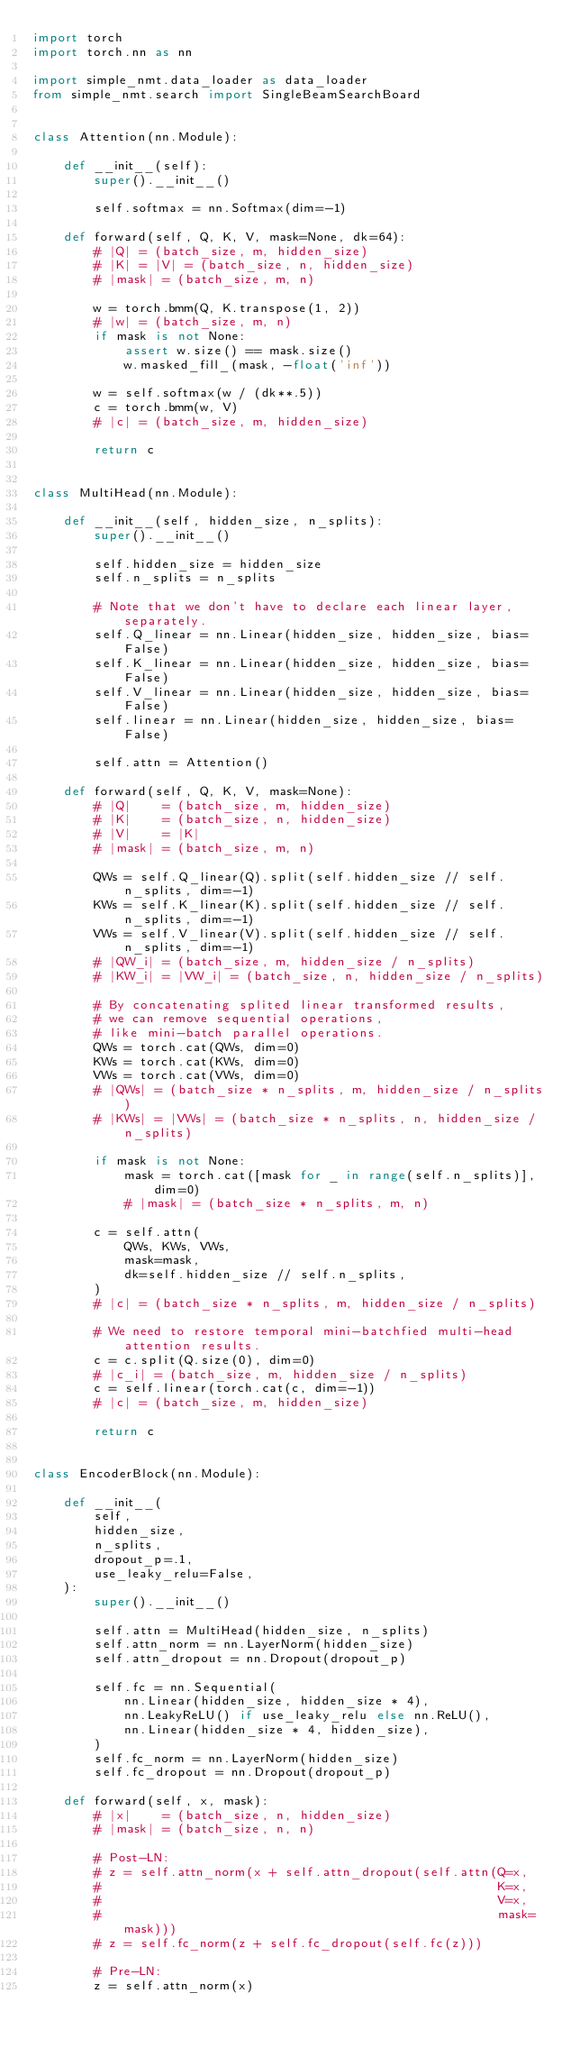Convert code to text. <code><loc_0><loc_0><loc_500><loc_500><_Python_>import torch
import torch.nn as nn

import simple_nmt.data_loader as data_loader
from simple_nmt.search import SingleBeamSearchBoard


class Attention(nn.Module):

    def __init__(self):
        super().__init__()

        self.softmax = nn.Softmax(dim=-1)

    def forward(self, Q, K, V, mask=None, dk=64):
        # |Q| = (batch_size, m, hidden_size)
        # |K| = |V| = (batch_size, n, hidden_size)
        # |mask| = (batch_size, m, n)

        w = torch.bmm(Q, K.transpose(1, 2))
        # |w| = (batch_size, m, n)
        if mask is not None:
            assert w.size() == mask.size()
            w.masked_fill_(mask, -float('inf'))

        w = self.softmax(w / (dk**.5))
        c = torch.bmm(w, V)
        # |c| = (batch_size, m, hidden_size)

        return c


class MultiHead(nn.Module):

    def __init__(self, hidden_size, n_splits):
        super().__init__()

        self.hidden_size = hidden_size
        self.n_splits = n_splits

        # Note that we don't have to declare each linear layer, separately.
        self.Q_linear = nn.Linear(hidden_size, hidden_size, bias=False)
        self.K_linear = nn.Linear(hidden_size, hidden_size, bias=False)
        self.V_linear = nn.Linear(hidden_size, hidden_size, bias=False)
        self.linear = nn.Linear(hidden_size, hidden_size, bias=False)

        self.attn = Attention()

    def forward(self, Q, K, V, mask=None):
        # |Q|    = (batch_size, m, hidden_size)
        # |K|    = (batch_size, n, hidden_size)
        # |V|    = |K|
        # |mask| = (batch_size, m, n)

        QWs = self.Q_linear(Q).split(self.hidden_size // self.n_splits, dim=-1)
        KWs = self.K_linear(K).split(self.hidden_size // self.n_splits, dim=-1)
        VWs = self.V_linear(V).split(self.hidden_size // self.n_splits, dim=-1)
        # |QW_i| = (batch_size, m, hidden_size / n_splits)
        # |KW_i| = |VW_i| = (batch_size, n, hidden_size / n_splits)

        # By concatenating splited linear transformed results,
        # we can remove sequential operations,
        # like mini-batch parallel operations.
        QWs = torch.cat(QWs, dim=0)
        KWs = torch.cat(KWs, dim=0)
        VWs = torch.cat(VWs, dim=0)
        # |QWs| = (batch_size * n_splits, m, hidden_size / n_splits)
        # |KWs| = |VWs| = (batch_size * n_splits, n, hidden_size / n_splits)

        if mask is not None:
            mask = torch.cat([mask for _ in range(self.n_splits)], dim=0)
            # |mask| = (batch_size * n_splits, m, n)

        c = self.attn(
            QWs, KWs, VWs,
            mask=mask,
            dk=self.hidden_size // self.n_splits,
        )
        # |c| = (batch_size * n_splits, m, hidden_size / n_splits)

        # We need to restore temporal mini-batchfied multi-head attention results.
        c = c.split(Q.size(0), dim=0)
        # |c_i| = (batch_size, m, hidden_size / n_splits)
        c = self.linear(torch.cat(c, dim=-1))
        # |c| = (batch_size, m, hidden_size)

        return c


class EncoderBlock(nn.Module):

    def __init__(
        self,
        hidden_size,
        n_splits,
        dropout_p=.1,
        use_leaky_relu=False,
    ):
        super().__init__()

        self.attn = MultiHead(hidden_size, n_splits)
        self.attn_norm = nn.LayerNorm(hidden_size)
        self.attn_dropout = nn.Dropout(dropout_p)

        self.fc = nn.Sequential(
            nn.Linear(hidden_size, hidden_size * 4),
            nn.LeakyReLU() if use_leaky_relu else nn.ReLU(),
            nn.Linear(hidden_size * 4, hidden_size),
        )
        self.fc_norm = nn.LayerNorm(hidden_size)
        self.fc_dropout = nn.Dropout(dropout_p)

    def forward(self, x, mask):
        # |x|    = (batch_size, n, hidden_size)
        # |mask| = (batch_size, n, n)

        # Post-LN:
        # z = self.attn_norm(x + self.attn_dropout(self.attn(Q=x,
        #                                                    K=x,
        #                                                    V=x,
        #                                                    mask=mask)))
        # z = self.fc_norm(z + self.fc_dropout(self.fc(z)))

        # Pre-LN:
        z = self.attn_norm(x)</code> 